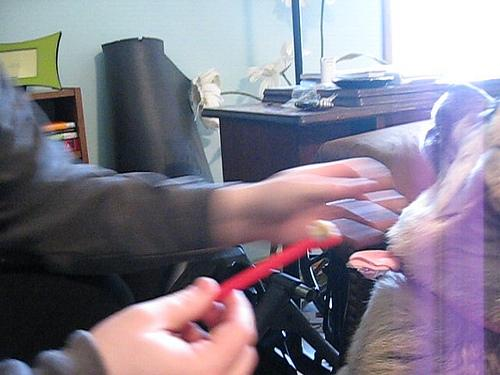What is the person trying to do to the dog? brush teeth 